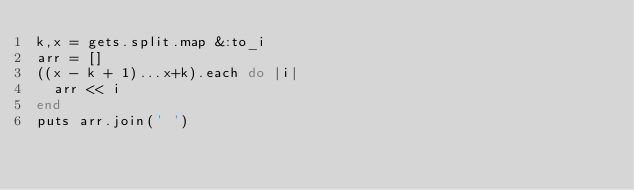Convert code to text. <code><loc_0><loc_0><loc_500><loc_500><_Ruby_>k,x = gets.split.map &:to_i
arr = []
((x - k + 1)...x+k).each do |i|
  arr << i
end
puts arr.join(' ')</code> 